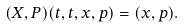Convert formula to latex. <formula><loc_0><loc_0><loc_500><loc_500>( X , P ) ( t , t , x , p ) = ( x , p ) .</formula> 